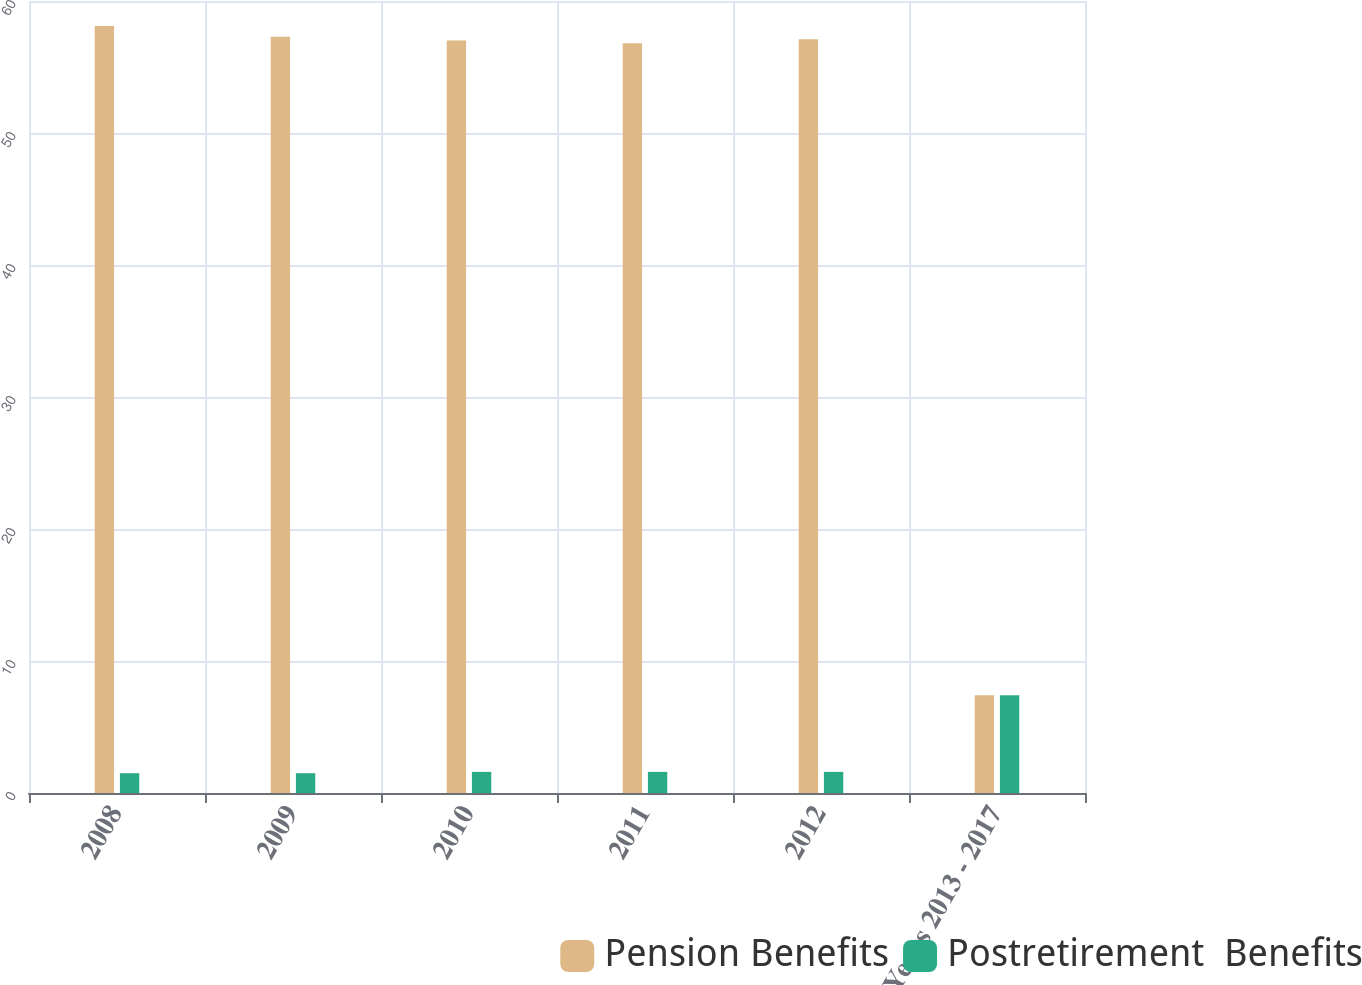Convert chart to OTSL. <chart><loc_0><loc_0><loc_500><loc_500><stacked_bar_chart><ecel><fcel>2008<fcel>2009<fcel>2010<fcel>2011<fcel>2012<fcel>Years 2013 - 2017<nl><fcel>Pension Benefits<fcel>58.1<fcel>57.3<fcel>57<fcel>56.8<fcel>57.1<fcel>7.4<nl><fcel>Postretirement  Benefits<fcel>1.5<fcel>1.5<fcel>1.6<fcel>1.6<fcel>1.6<fcel>7.4<nl></chart> 